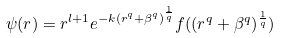Convert formula to latex. <formula><loc_0><loc_0><loc_500><loc_500>\psi ( r ) = r ^ { l + 1 } e ^ { - k ( r ^ { q } + \beta ^ { q } ) ^ { \frac { 1 } { q } } } f ( ( r ^ { q } + \beta ^ { q } ) ^ { \frac { 1 } { q } } )</formula> 